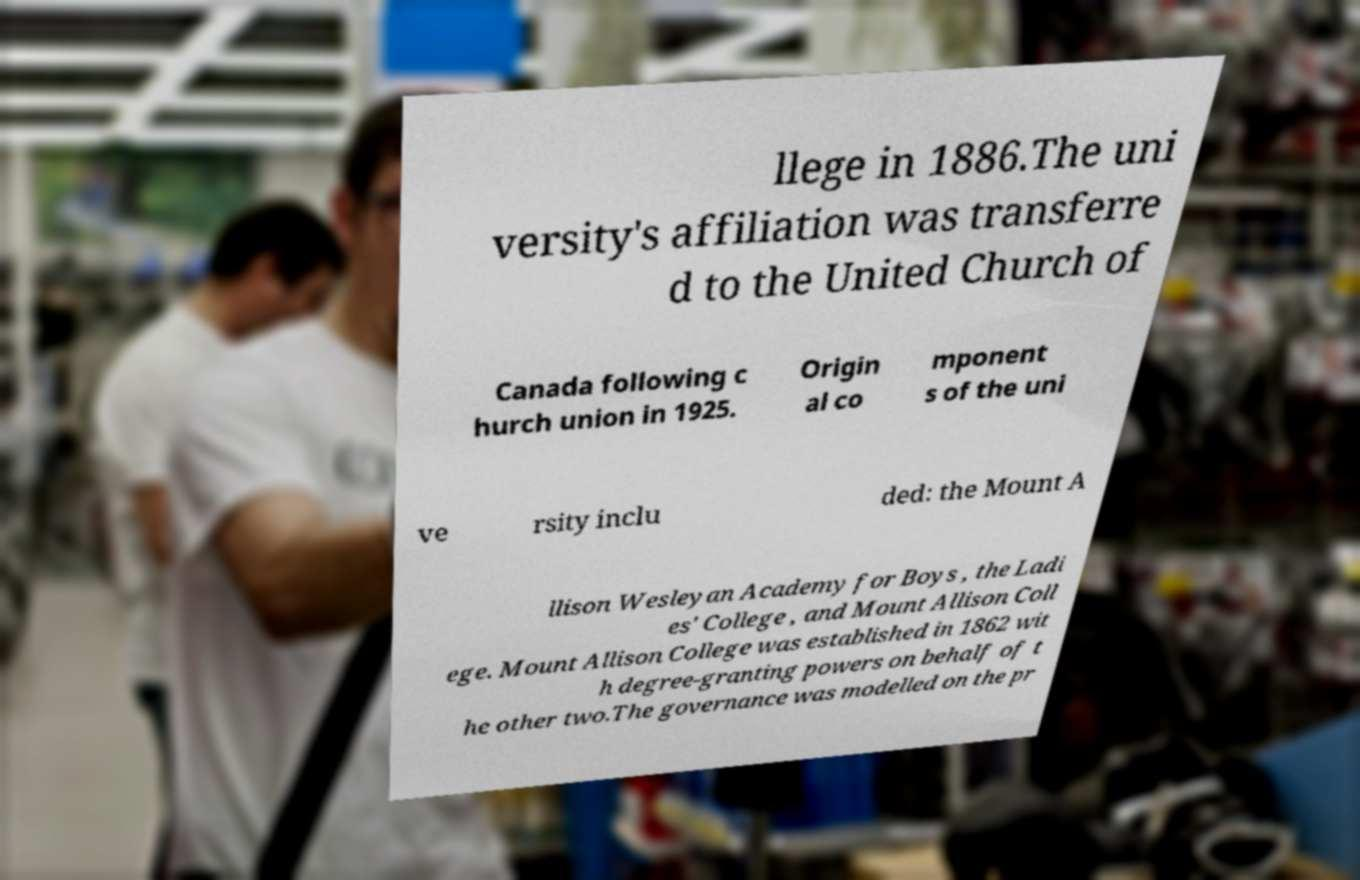I need the written content from this picture converted into text. Can you do that? llege in 1886.The uni versity's affiliation was transferre d to the United Church of Canada following c hurch union in 1925. Origin al co mponent s of the uni ve rsity inclu ded: the Mount A llison Wesleyan Academy for Boys , the Ladi es' College , and Mount Allison Coll ege. Mount Allison College was established in 1862 wit h degree-granting powers on behalf of t he other two.The governance was modelled on the pr 